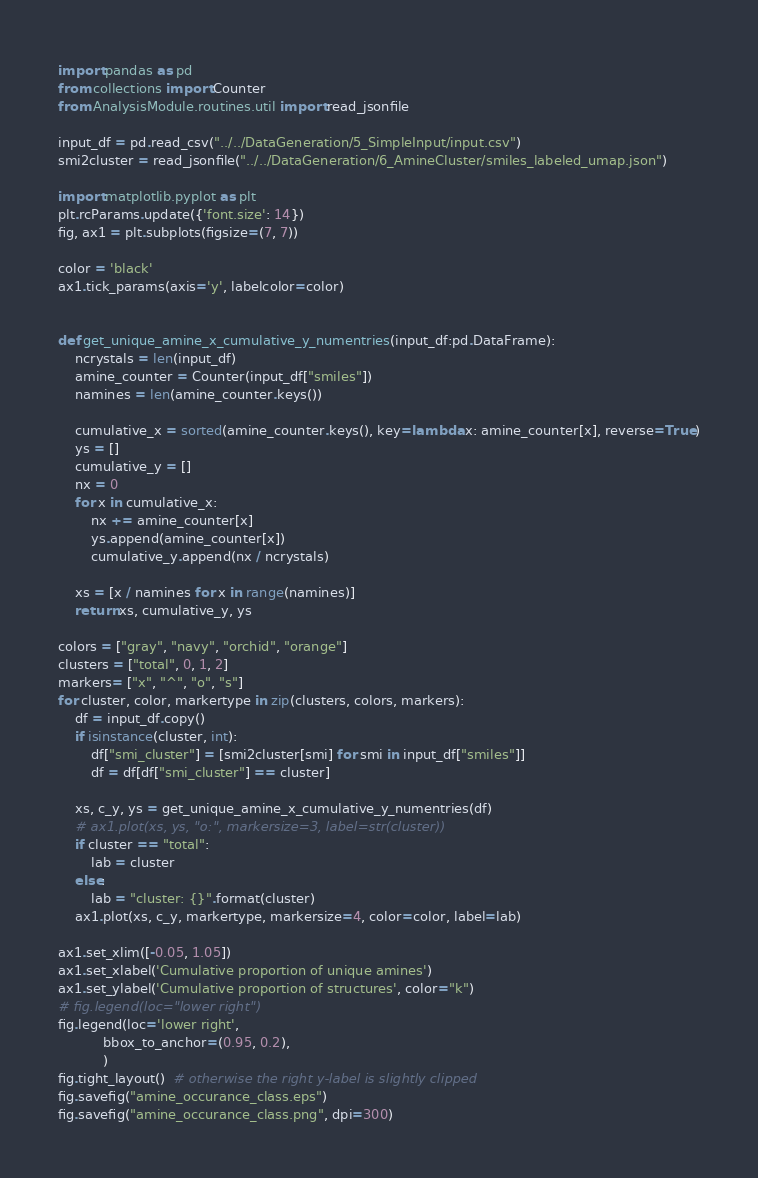Convert code to text. <code><loc_0><loc_0><loc_500><loc_500><_Python_>import pandas as pd
from collections import Counter
from AnalysisModule.routines.util import read_jsonfile

input_df = pd.read_csv("../../DataGeneration/5_SimpleInput/input.csv")
smi2cluster = read_jsonfile("../../DataGeneration/6_AmineCluster/smiles_labeled_umap.json")

import matplotlib.pyplot as plt
plt.rcParams.update({'font.size': 14})
fig, ax1 = plt.subplots(figsize=(7, 7))

color = 'black'
ax1.tick_params(axis='y', labelcolor=color)


def get_unique_amine_x_cumulative_y_numentries(input_df:pd.DataFrame):
    ncrystals = len(input_df)
    amine_counter = Counter(input_df["smiles"])
    namines = len(amine_counter.keys())

    cumulative_x = sorted(amine_counter.keys(), key=lambda x: amine_counter[x], reverse=True)
    ys = []
    cumulative_y = []
    nx = 0
    for x in cumulative_x:
        nx += amine_counter[x]
        ys.append(amine_counter[x])
        cumulative_y.append(nx / ncrystals)

    xs = [x / namines for x in range(namines)]
    return xs, cumulative_y, ys

colors = ["gray", "navy", "orchid", "orange"]
clusters = ["total", 0, 1, 2]
markers= ["x", "^", "o", "s"]
for cluster, color, markertype in zip(clusters, colors, markers):
    df = input_df.copy()
    if isinstance(cluster, int):
        df["smi_cluster"] = [smi2cluster[smi] for smi in input_df["smiles"]]
        df = df[df["smi_cluster"] == cluster]

    xs, c_y, ys = get_unique_amine_x_cumulative_y_numentries(df)
    # ax1.plot(xs, ys, "o:", markersize=3, label=str(cluster))
    if cluster == "total":
        lab = cluster
    else:
        lab = "cluster: {}".format(cluster)
    ax1.plot(xs, c_y, markertype, markersize=4, color=color, label=lab)

ax1.set_xlim([-0.05, 1.05])
ax1.set_xlabel('Cumulative proportion of unique amines')
ax1.set_ylabel('Cumulative proportion of structures', color="k")
# fig.legend(loc="lower right")
fig.legend(loc='lower right',
           bbox_to_anchor=(0.95, 0.2),
           )
fig.tight_layout()  # otherwise the right y-label is slightly clipped
fig.savefig("amine_occurance_class.eps")
fig.savefig("amine_occurance_class.png", dpi=300)


</code> 